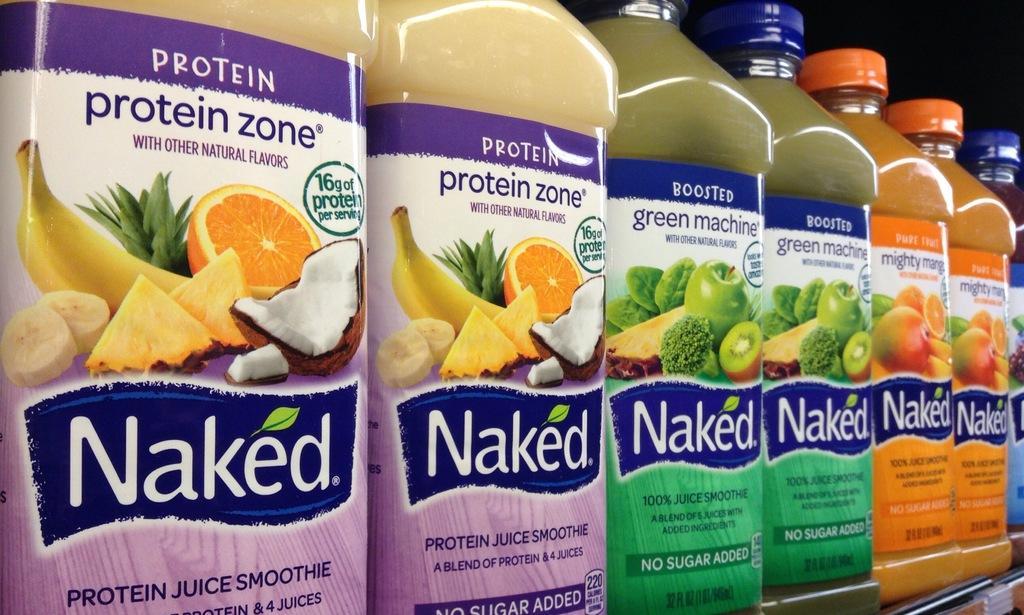How would you summarize this image in a sentence or two? In this image there are bottles, in that bottles there is food item. 